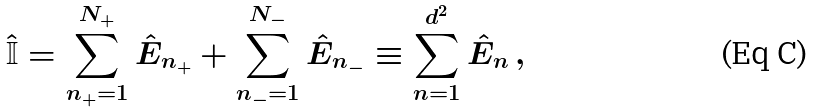<formula> <loc_0><loc_0><loc_500><loc_500>\hat { \mathbb { I } } = \sum _ { n _ { + } = 1 } ^ { N _ { + } } \hat { E } _ { n _ { + } } + \sum _ { n _ { - } = 1 } ^ { N _ { - } } \hat { E } _ { n _ { - } } \equiv \sum _ { n = 1 } ^ { d ^ { 2 } } \hat { E } _ { n } \, ,</formula> 